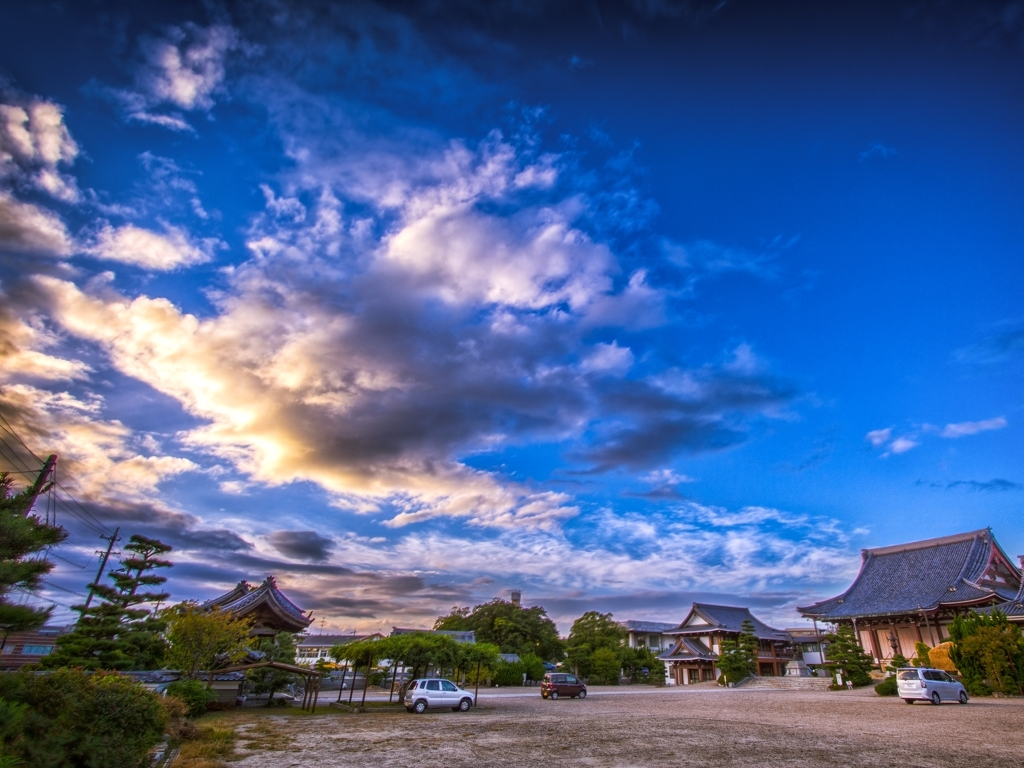How does the lighting in this image affect its overall mood? The lighting in the image, with the sun casting a soft glow on the edges of the clouds, gives a serene yet dramatic effect, enhancing the natural beauty of the scene. It creates a tranquil atmosphere with a hint of inspiration and majesty. The contrast between light and shadow brings depth to the composition, guiding the viewer's eye across the landscape. 